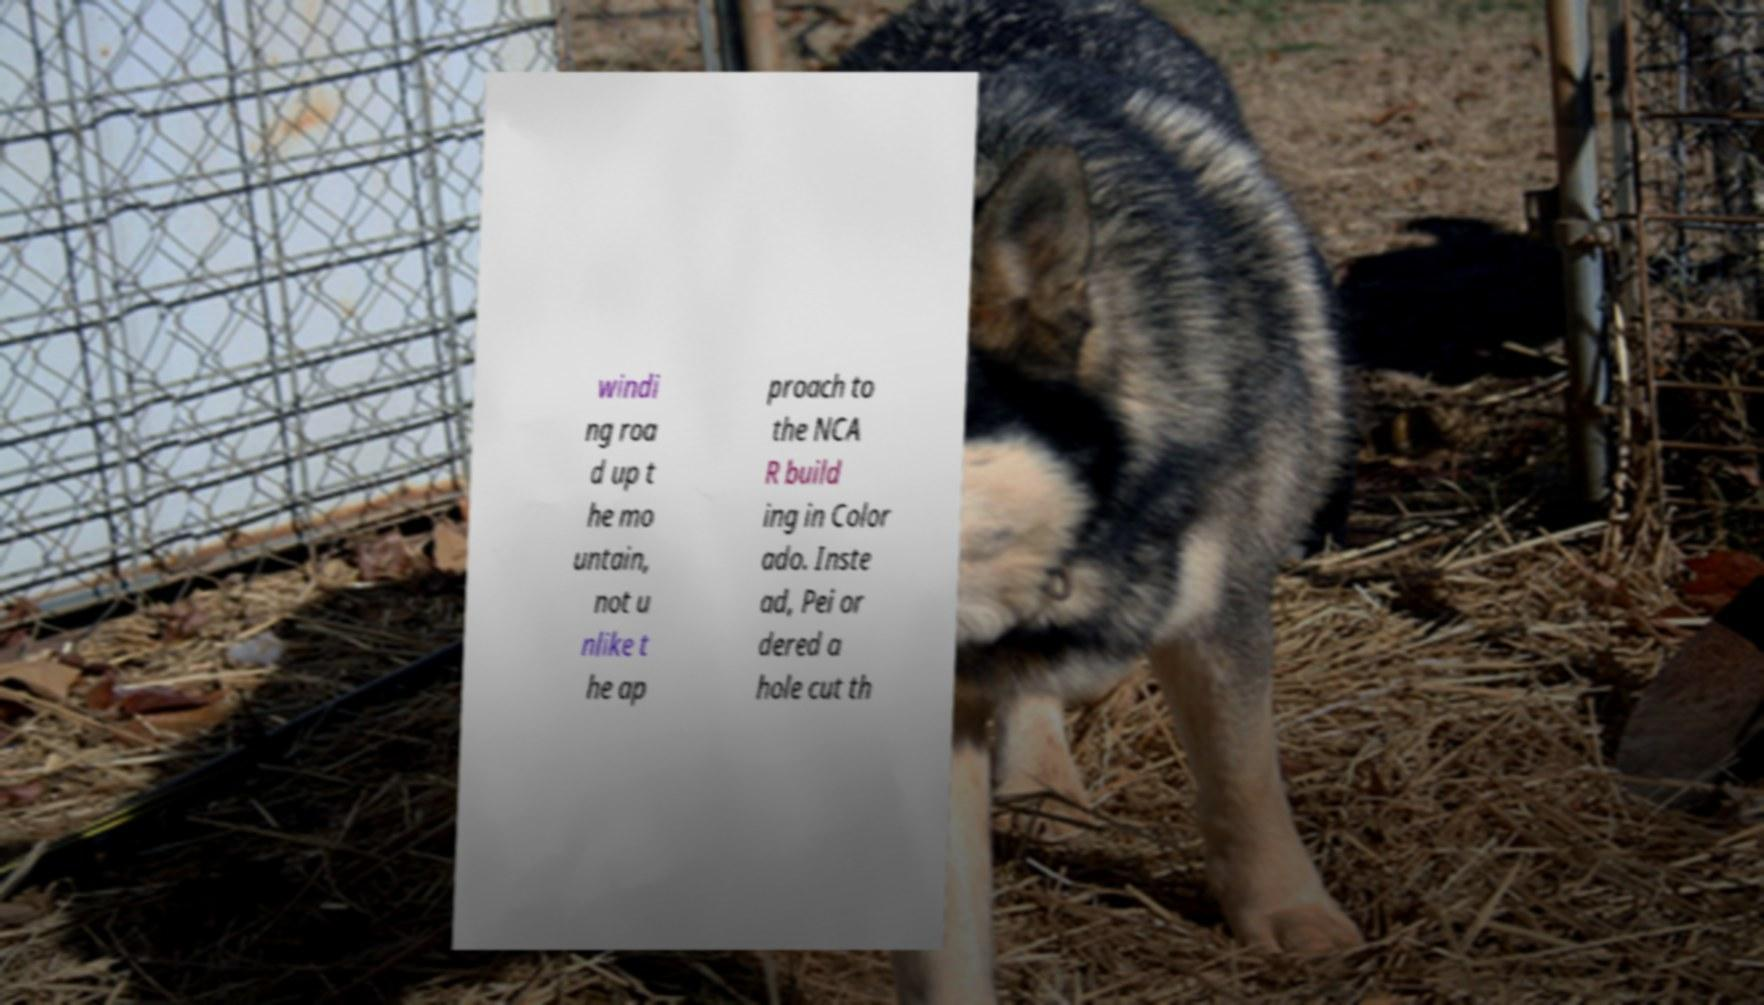I need the written content from this picture converted into text. Can you do that? windi ng roa d up t he mo untain, not u nlike t he ap proach to the NCA R build ing in Color ado. Inste ad, Pei or dered a hole cut th 